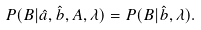Convert formula to latex. <formula><loc_0><loc_0><loc_500><loc_500>P ( B | \hat { a } , \hat { b } , A , \lambda ) = P ( B | \hat { b } , \lambda ) .</formula> 